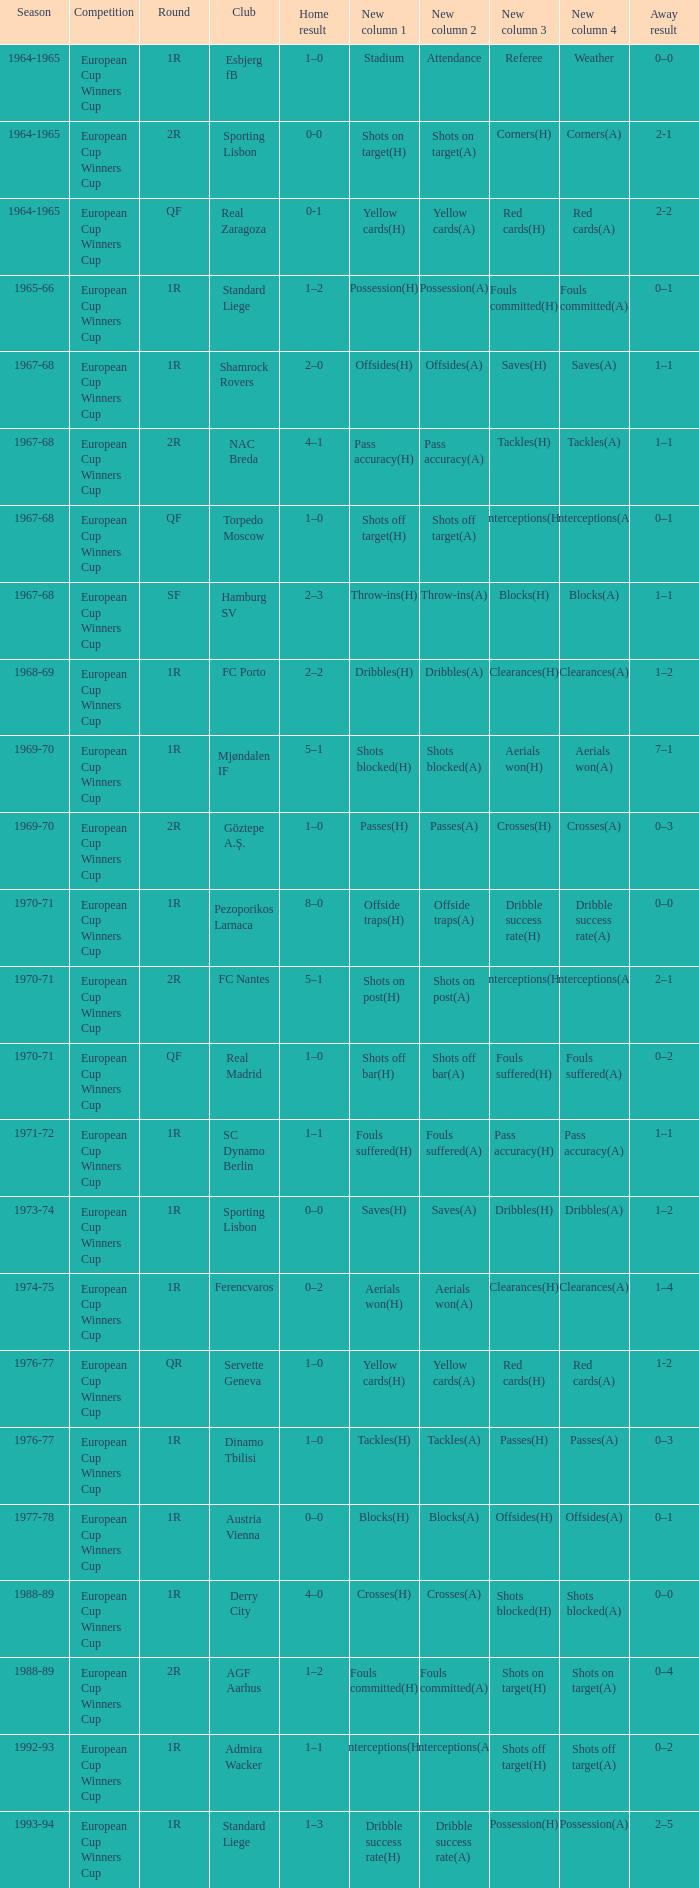Round of 1r, and an away result of 7–1 is what season? 1969-70. 